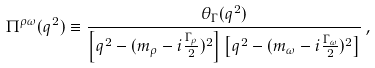Convert formula to latex. <formula><loc_0><loc_0><loc_500><loc_500>\Pi ^ { \rho \omega } ( q ^ { 2 } ) \equiv \frac { \theta _ { \Gamma } ( q ^ { 2 } ) } { \left [ q ^ { 2 } - ( m _ { \rho } - i \frac { \Gamma _ { \rho } } { 2 } ) ^ { 2 } \right ] \left [ q ^ { 2 } - ( m _ { \omega } - i \frac { \Gamma _ { \omega } } { 2 } ) ^ { 2 } \right ] } \, ,</formula> 